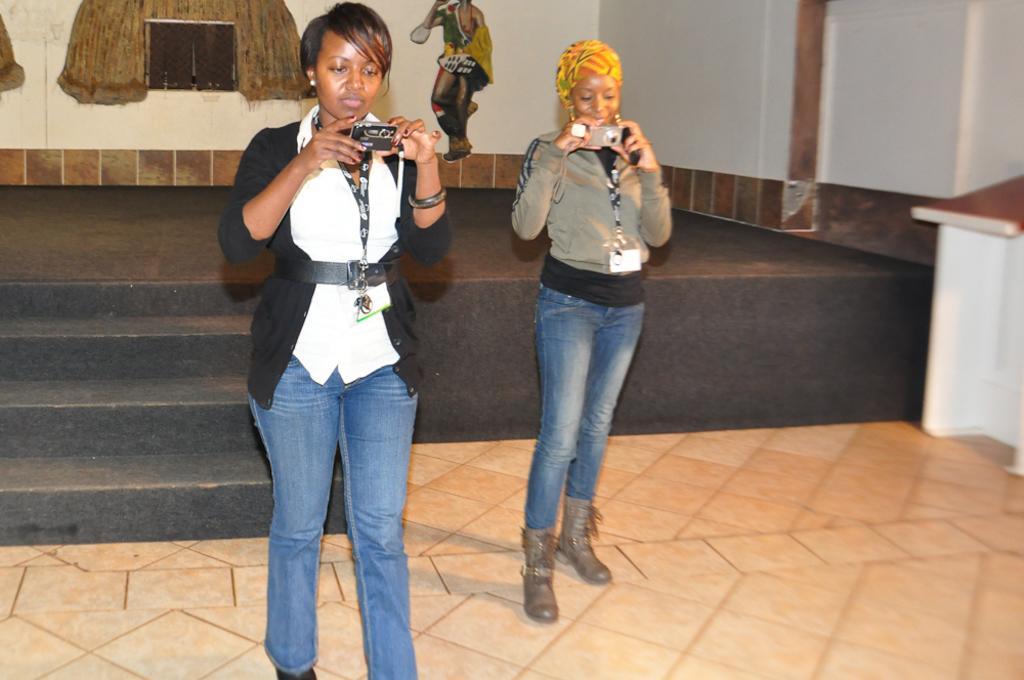Could you give a brief overview of what you see in this image? In this picture we can see there are two women standing on the floor and the woman holding some objects. Behind the women there is the stage and there are some decorative objects on the wall. 